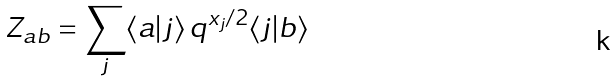<formula> <loc_0><loc_0><loc_500><loc_500>Z _ { a b } = \sum _ { j } \langle a | j \rangle \, q ^ { x _ { j } / 2 } \langle j | b \rangle</formula> 